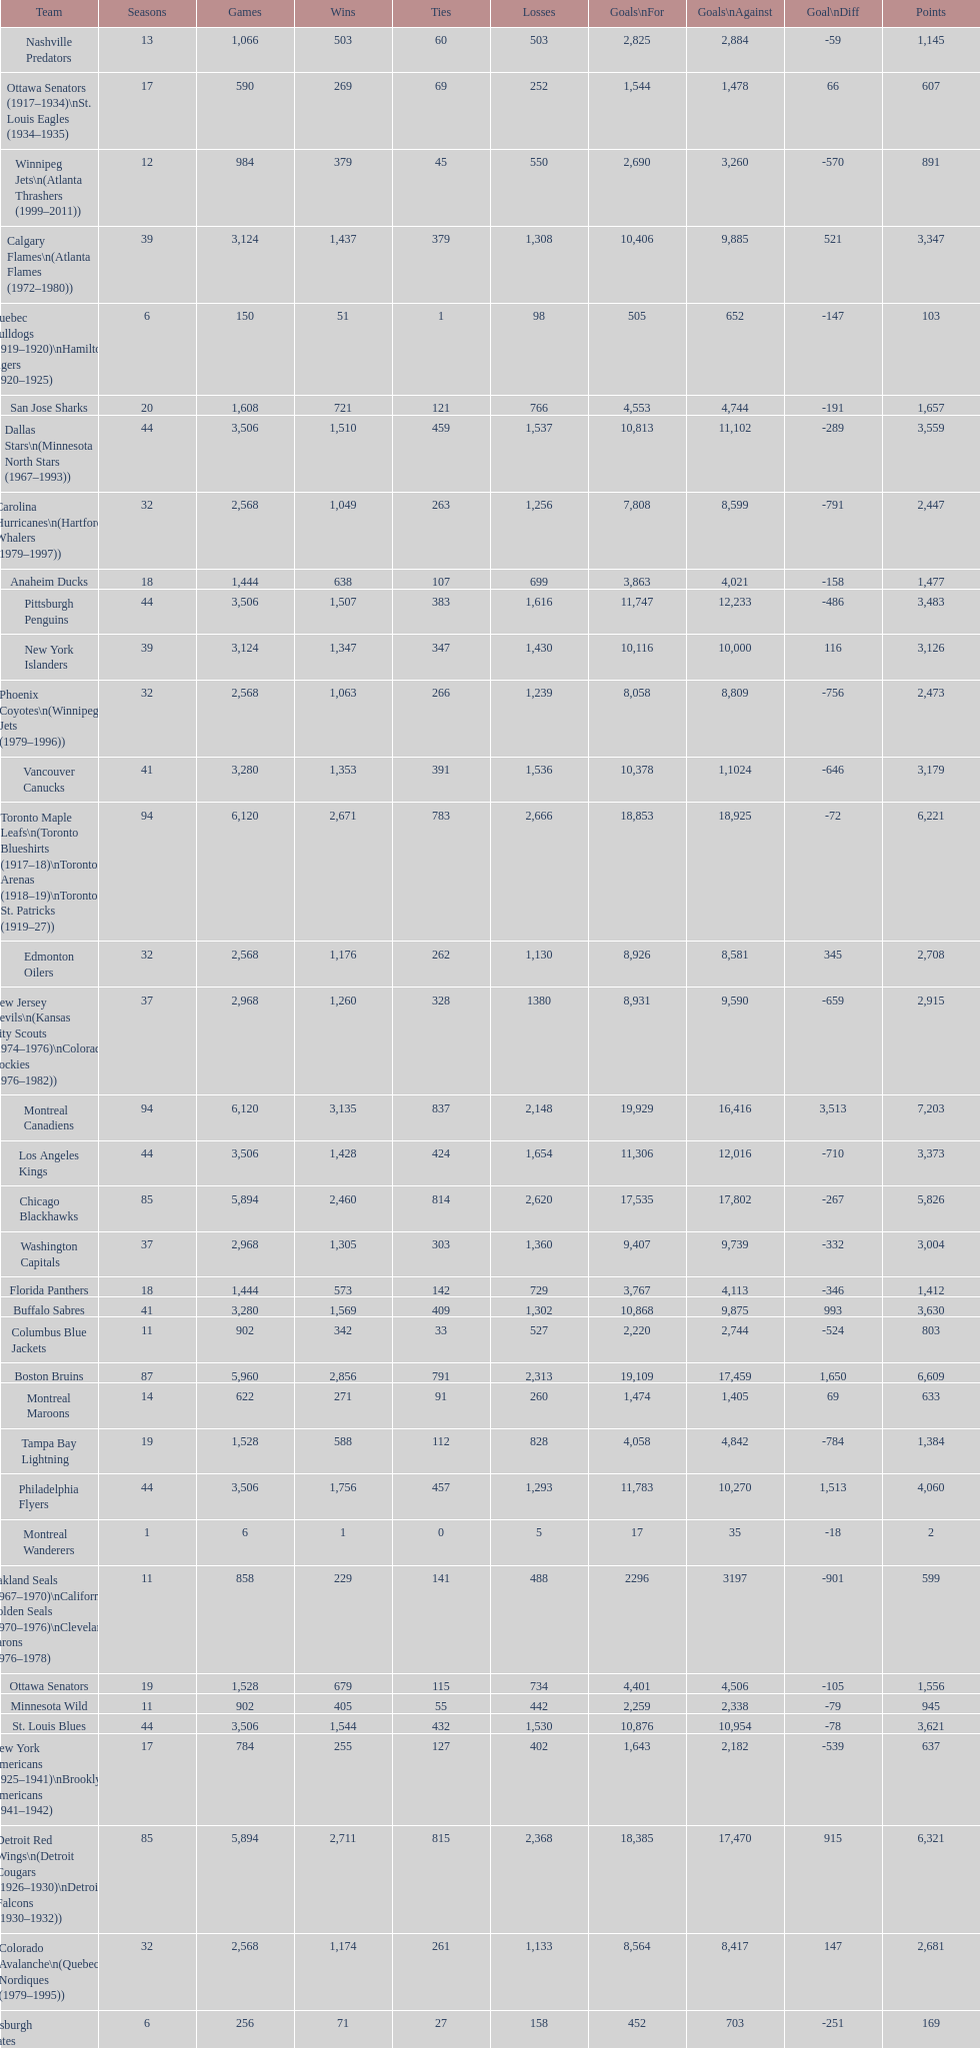How many losses do the st. louis blues have? 1,530. 